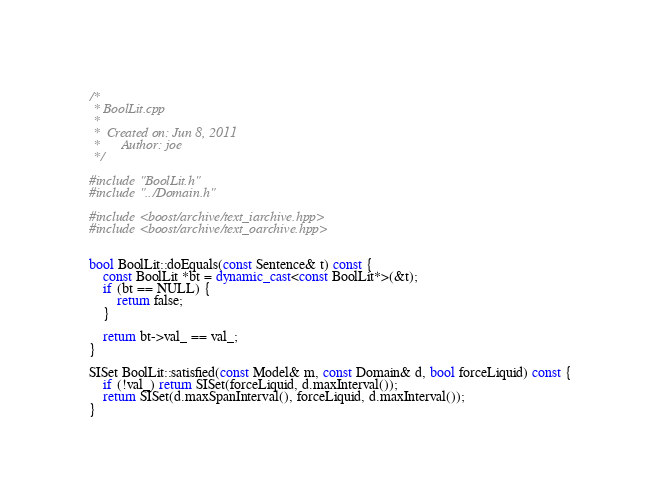Convert code to text. <code><loc_0><loc_0><loc_500><loc_500><_C++_>/*
 * BoolLit.cpp
 *
 *  Created on: Jun 8, 2011
 *      Author: joe
 */

#include "BoolLit.h"
#include "../Domain.h"

#include <boost/archive/text_iarchive.hpp>
#include <boost/archive/text_oarchive.hpp>


bool BoolLit::doEquals(const Sentence& t) const {
    const BoolLit *bt = dynamic_cast<const BoolLit*>(&t);
    if (bt == NULL) {
        return false;
    }

    return bt->val_ == val_;
}

SISet BoolLit::satisfied(const Model& m, const Domain& d, bool forceLiquid) const {
    if (!val_) return SISet(forceLiquid, d.maxInterval());
    return SISet(d.maxSpanInterval(), forceLiquid, d.maxInterval());
}
</code> 